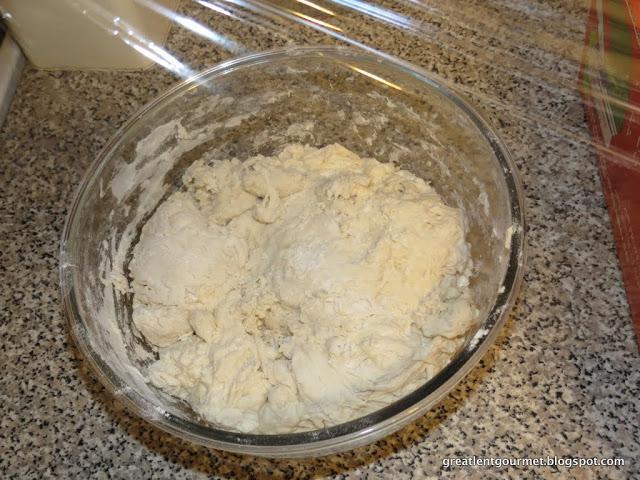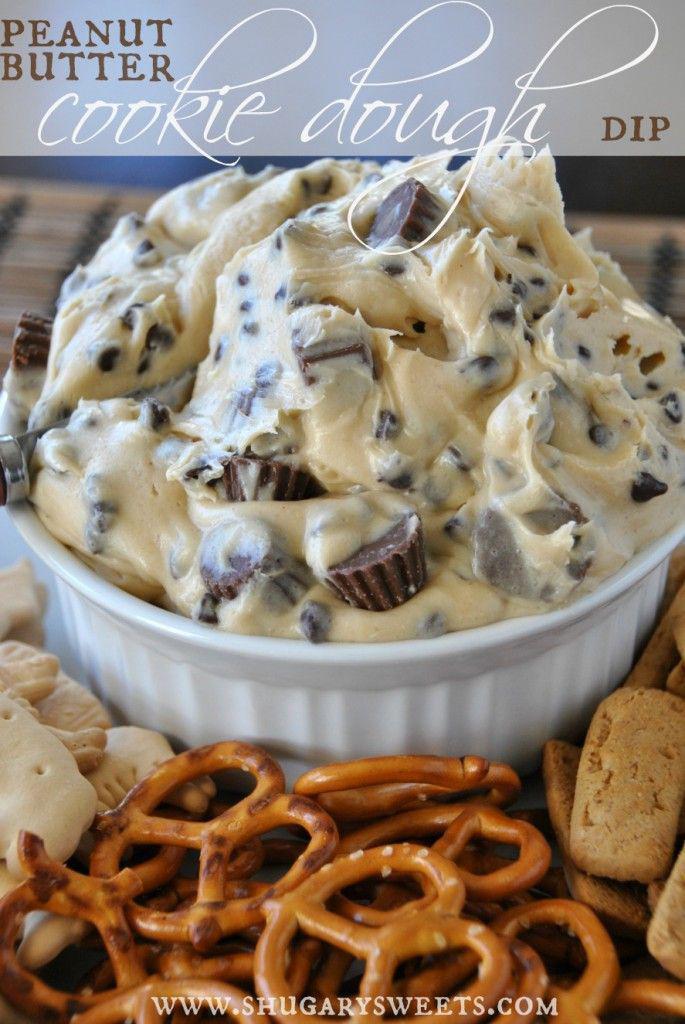The first image is the image on the left, the second image is the image on the right. Evaluate the accuracy of this statement regarding the images: "There are multiple raw cookies on a baking sheet.". Is it true? Answer yes or no. No. The first image is the image on the left, the second image is the image on the right. Assess this claim about the two images: "The right image features mounds of raw cookie dough in rows with a metal sheet under them.". Correct or not? Answer yes or no. No. 